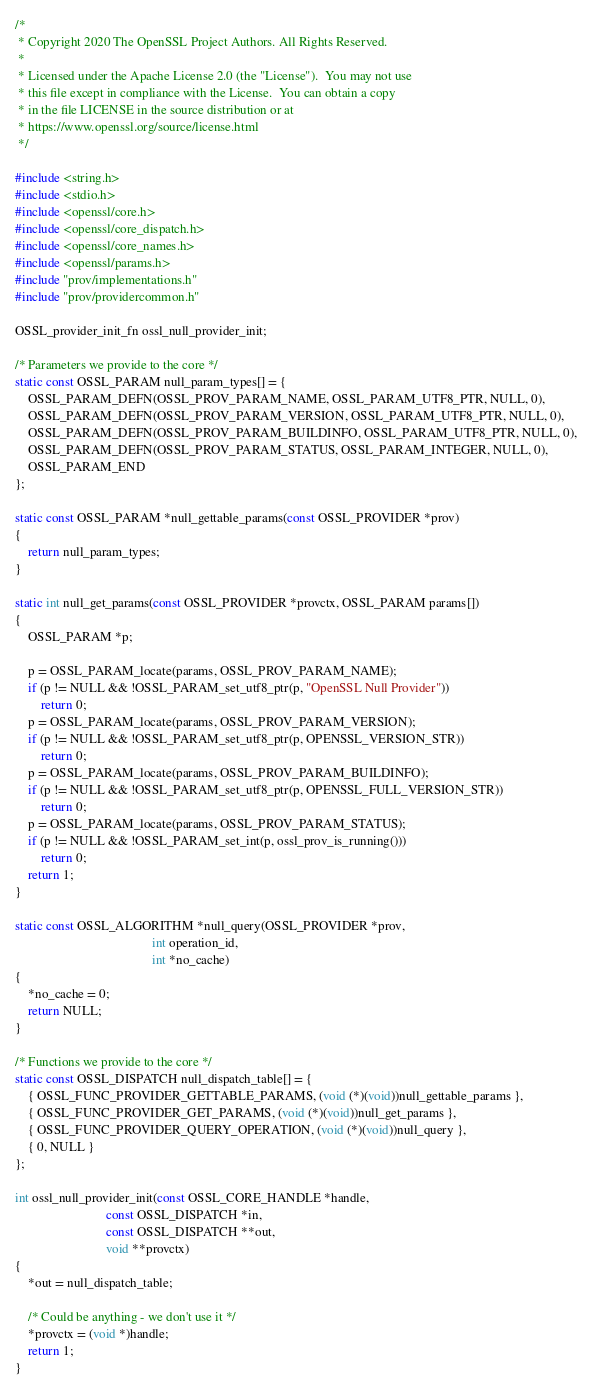<code> <loc_0><loc_0><loc_500><loc_500><_C_>/*
 * Copyright 2020 The OpenSSL Project Authors. All Rights Reserved.
 *
 * Licensed under the Apache License 2.0 (the "License").  You may not use
 * this file except in compliance with the License.  You can obtain a copy
 * in the file LICENSE in the source distribution or at
 * https://www.openssl.org/source/license.html
 */

#include <string.h>
#include <stdio.h>
#include <openssl/core.h>
#include <openssl/core_dispatch.h>
#include <openssl/core_names.h>
#include <openssl/params.h>
#include "prov/implementations.h"
#include "prov/providercommon.h"

OSSL_provider_init_fn ossl_null_provider_init;

/* Parameters we provide to the core */
static const OSSL_PARAM null_param_types[] = {
    OSSL_PARAM_DEFN(OSSL_PROV_PARAM_NAME, OSSL_PARAM_UTF8_PTR, NULL, 0),
    OSSL_PARAM_DEFN(OSSL_PROV_PARAM_VERSION, OSSL_PARAM_UTF8_PTR, NULL, 0),
    OSSL_PARAM_DEFN(OSSL_PROV_PARAM_BUILDINFO, OSSL_PARAM_UTF8_PTR, NULL, 0),
    OSSL_PARAM_DEFN(OSSL_PROV_PARAM_STATUS, OSSL_PARAM_INTEGER, NULL, 0),
    OSSL_PARAM_END
};

static const OSSL_PARAM *null_gettable_params(const OSSL_PROVIDER *prov)
{
    return null_param_types;
}

static int null_get_params(const OSSL_PROVIDER *provctx, OSSL_PARAM params[])
{
    OSSL_PARAM *p;

    p = OSSL_PARAM_locate(params, OSSL_PROV_PARAM_NAME);
    if (p != NULL && !OSSL_PARAM_set_utf8_ptr(p, "OpenSSL Null Provider"))
        return 0;
    p = OSSL_PARAM_locate(params, OSSL_PROV_PARAM_VERSION);
    if (p != NULL && !OSSL_PARAM_set_utf8_ptr(p, OPENSSL_VERSION_STR))
        return 0;
    p = OSSL_PARAM_locate(params, OSSL_PROV_PARAM_BUILDINFO);
    if (p != NULL && !OSSL_PARAM_set_utf8_ptr(p, OPENSSL_FULL_VERSION_STR))
        return 0;
    p = OSSL_PARAM_locate(params, OSSL_PROV_PARAM_STATUS);
    if (p != NULL && !OSSL_PARAM_set_int(p, ossl_prov_is_running()))
        return 0;
    return 1;
}

static const OSSL_ALGORITHM *null_query(OSSL_PROVIDER *prov,
                                          int operation_id,
                                          int *no_cache)
{
    *no_cache = 0;
    return NULL;
}

/* Functions we provide to the core */
static const OSSL_DISPATCH null_dispatch_table[] = {
    { OSSL_FUNC_PROVIDER_GETTABLE_PARAMS, (void (*)(void))null_gettable_params },
    { OSSL_FUNC_PROVIDER_GET_PARAMS, (void (*)(void))null_get_params },
    { OSSL_FUNC_PROVIDER_QUERY_OPERATION, (void (*)(void))null_query },
    { 0, NULL }
};

int ossl_null_provider_init(const OSSL_CORE_HANDLE *handle,
                            const OSSL_DISPATCH *in,
                            const OSSL_DISPATCH **out,
                            void **provctx)
{
    *out = null_dispatch_table;

    /* Could be anything - we don't use it */
    *provctx = (void *)handle;
    return 1;
}
</code> 